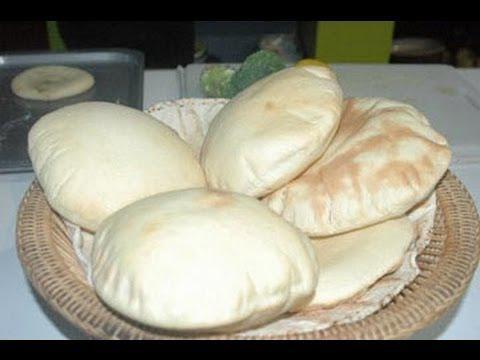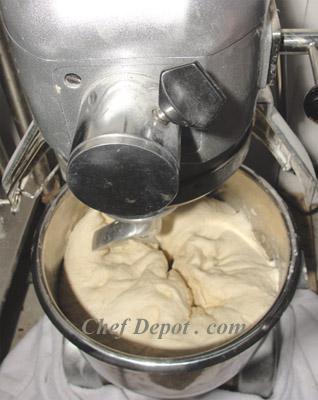The first image is the image on the left, the second image is the image on the right. Considering the images on both sides, is "The images show two different stages of dough in a mixer." valid? Answer yes or no. No. 